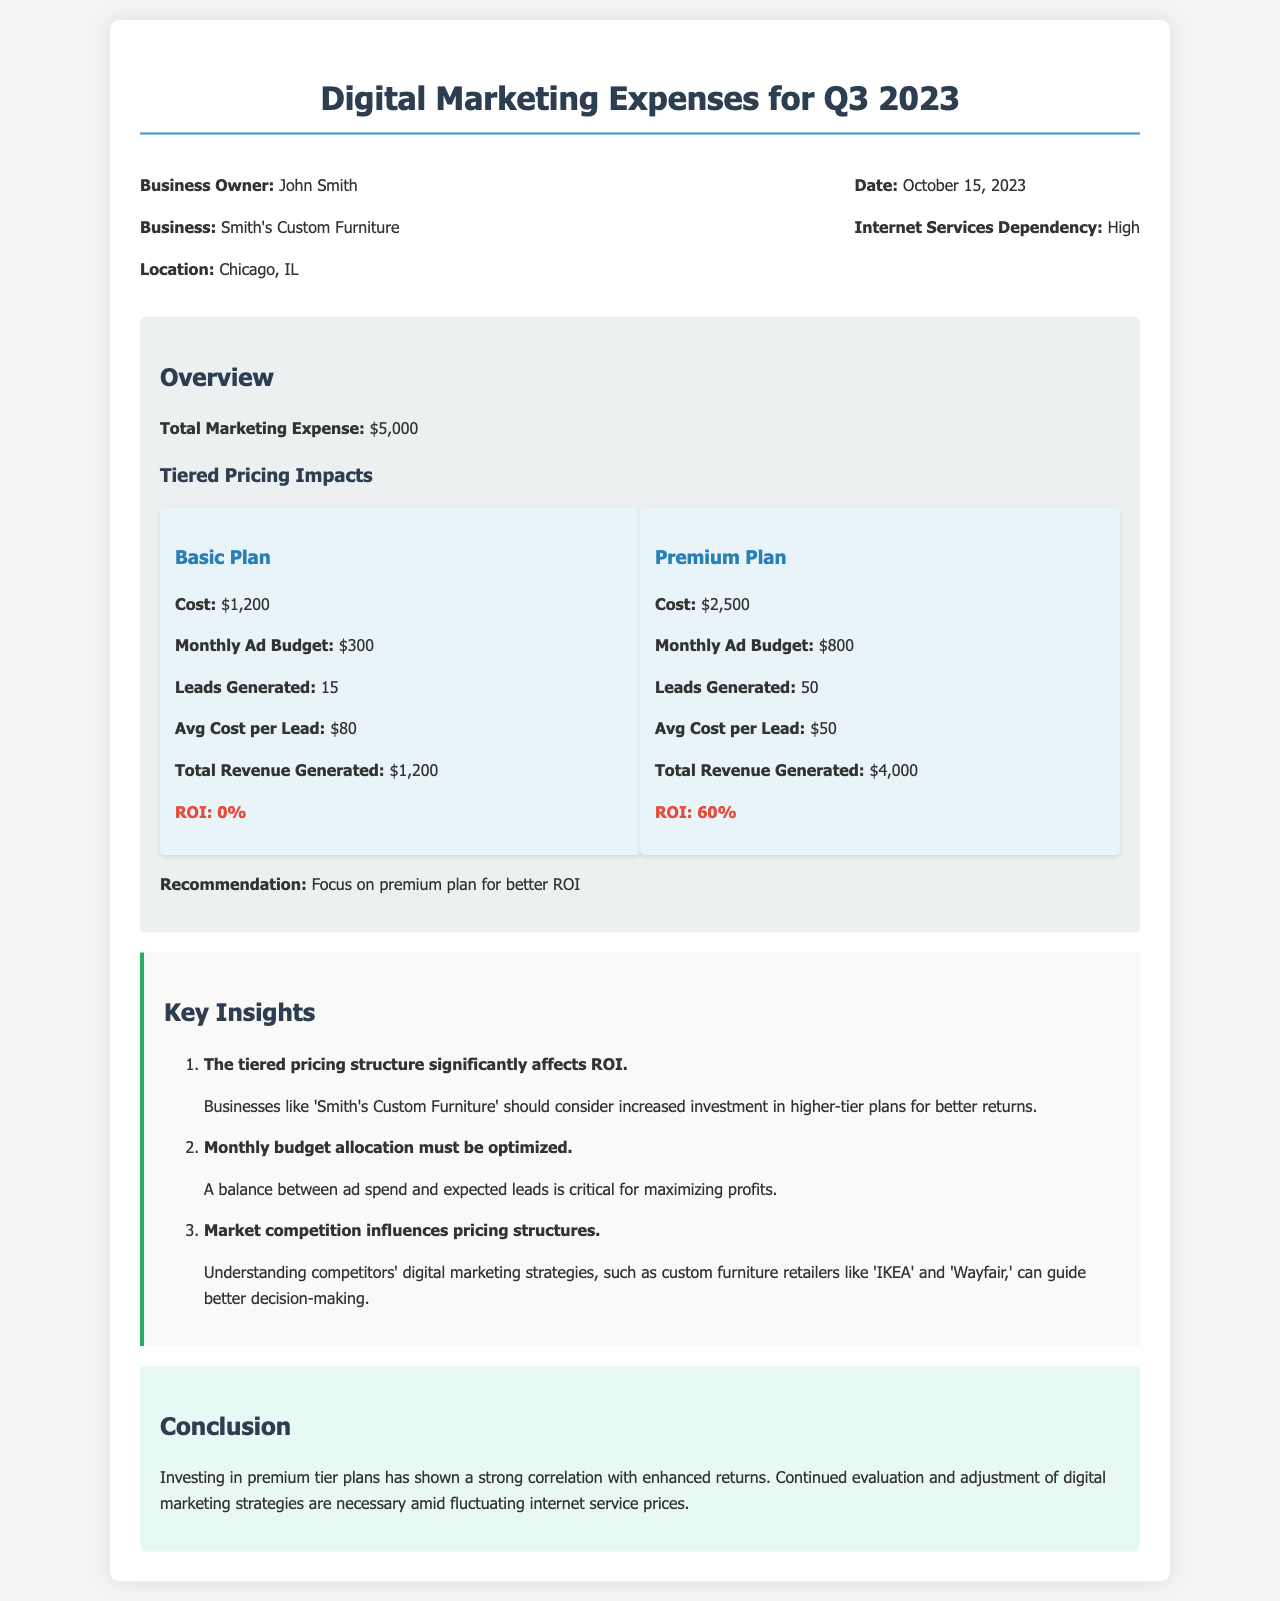what is the total marketing expense? The total marketing expense is stated clearly in the overview section of the document.
Answer: $5,000 who is the business owner? The document identifies the business owner in the header information section.
Answer: John Smith what is the ROI for the Basic Plan? The ROI for the Basic Plan is provided in the plan comparison section.
Answer: 0% how many leads were generated by the Premium Plan? The number of leads generated is mentioned in the plan comparison section for the Premium Plan.
Answer: 50 what is the recommendation given in the document? The recommendation is found in the overview section and suggests a course of action based on the analysis.
Answer: Focus on premium plan for better ROI what does the conclusion emphasize about premium tier plans? The conclusion provides insights into the effectiveness of investments in premium tier plans specifically.
Answer: Strong correlation with enhanced returns how does market competition influence pricing structures according to the document? The insights section discusses the significance of market competition influencing marketing strategies and pricing.
Answer: Influences pricing structures what should be optimized according to Key Insights? The Key Insights section identifies an important area for improvement regarding budget allocation.
Answer: Monthly budget allocation 